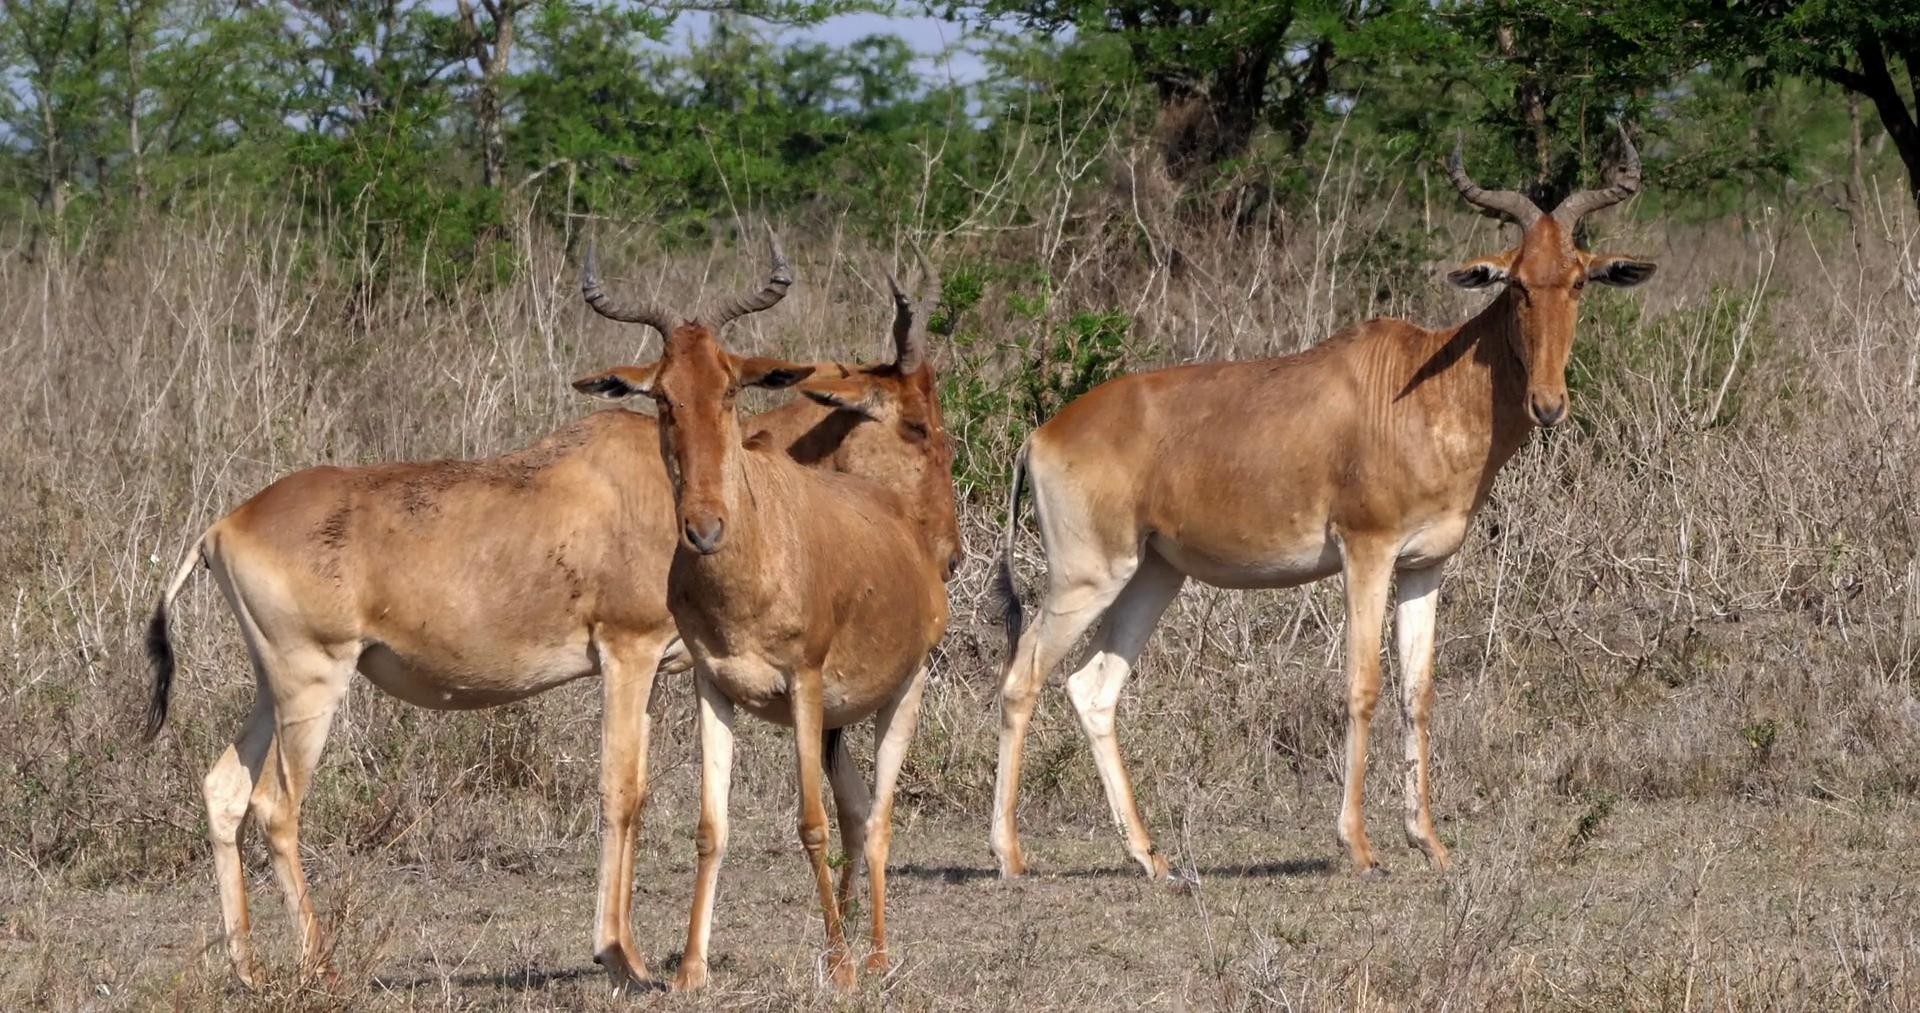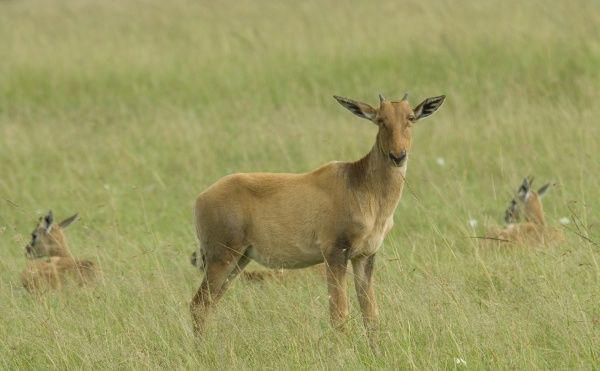The first image is the image on the left, the second image is the image on the right. Examine the images to the left and right. Is the description "The left image contains at least three antelopes." accurate? Answer yes or no. Yes. The first image is the image on the left, the second image is the image on the right. Considering the images on both sides, is "Three horned animals in standing poses are in the image on the left." valid? Answer yes or no. Yes. 